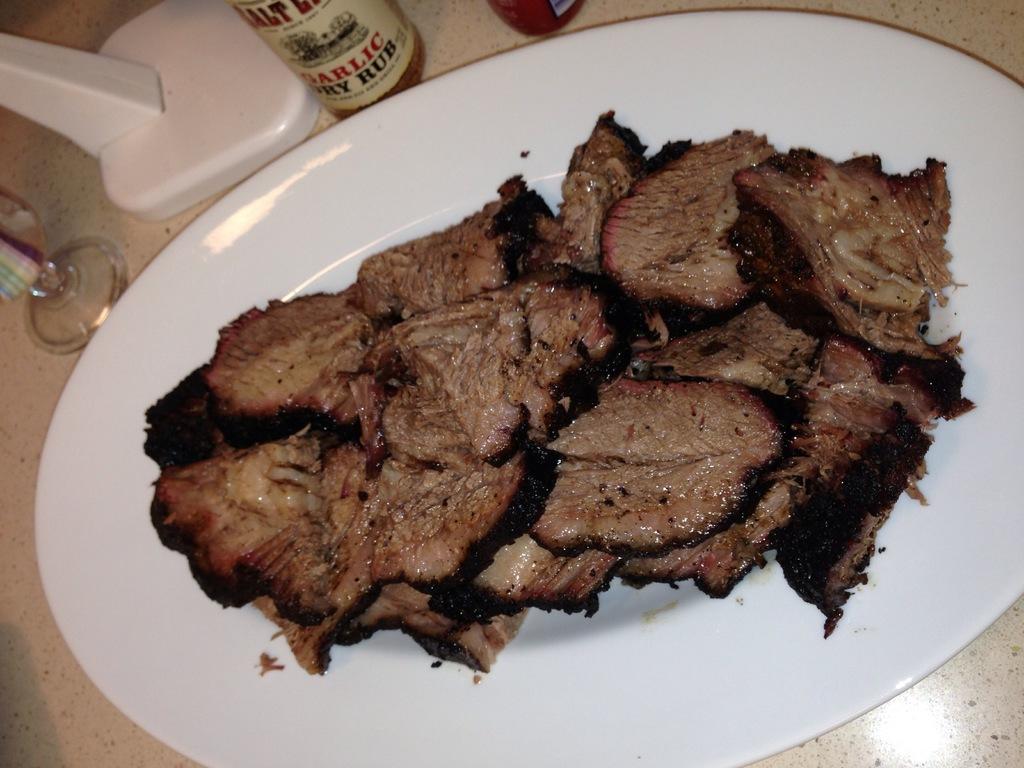What kind of rub is being put on the steak?
Make the answer very short. Garlic dry rub. 